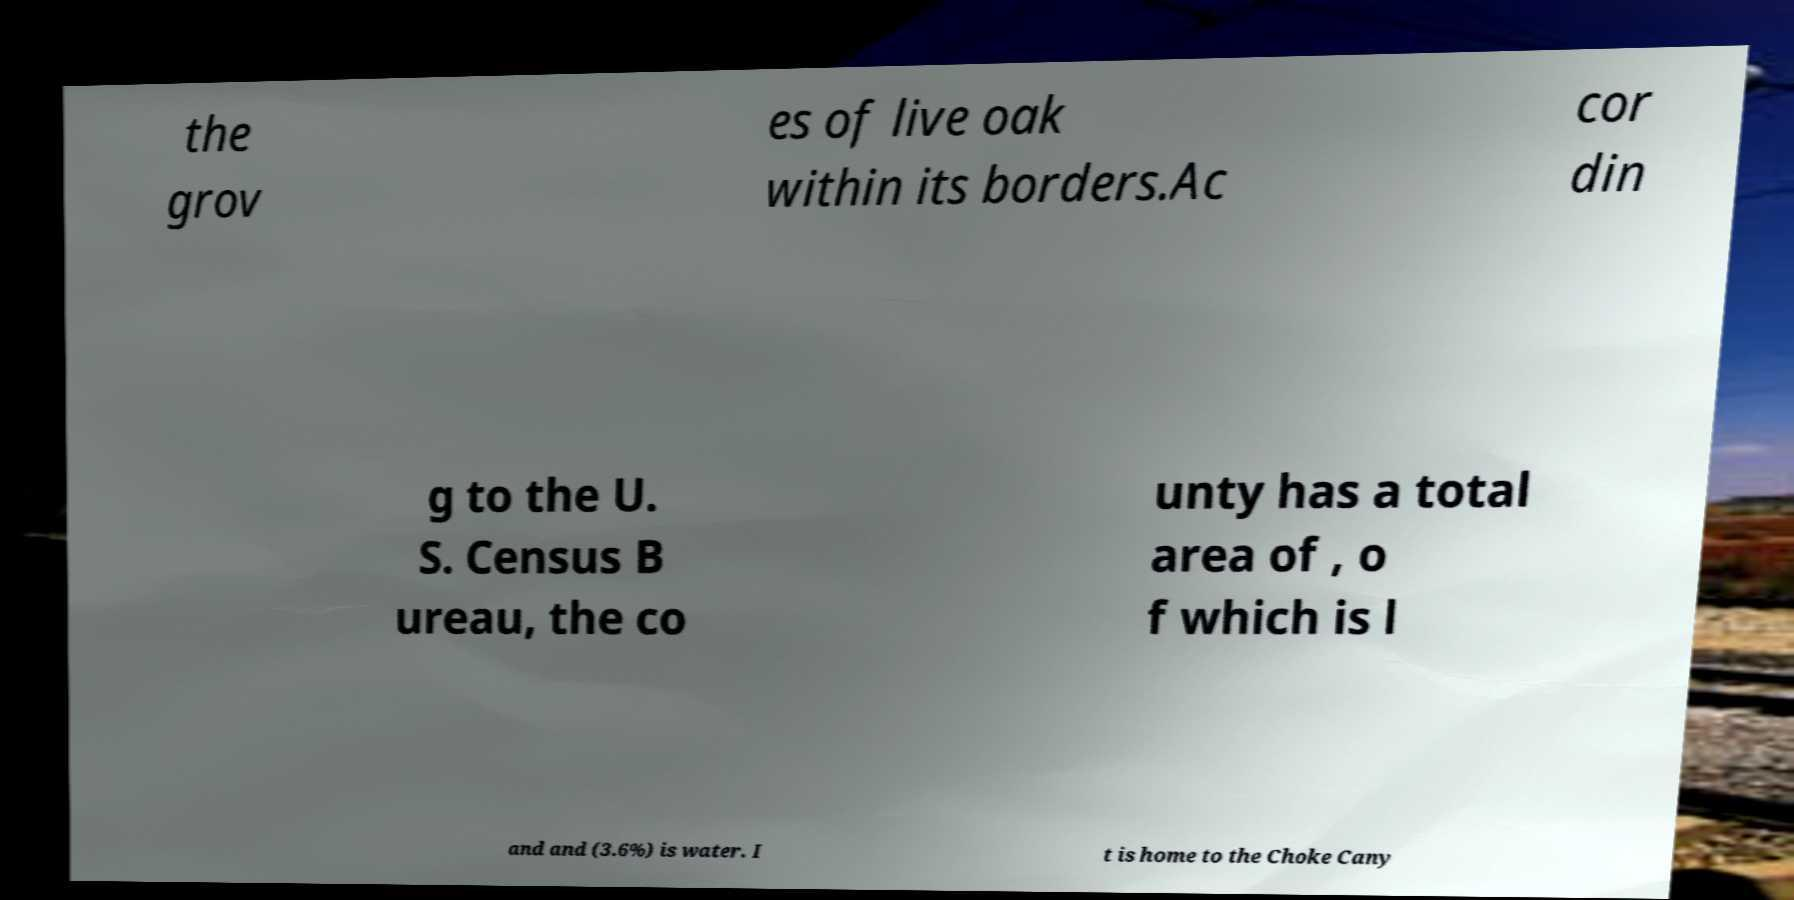There's text embedded in this image that I need extracted. Can you transcribe it verbatim? the grov es of live oak within its borders.Ac cor din g to the U. S. Census B ureau, the co unty has a total area of , o f which is l and and (3.6%) is water. I t is home to the Choke Cany 